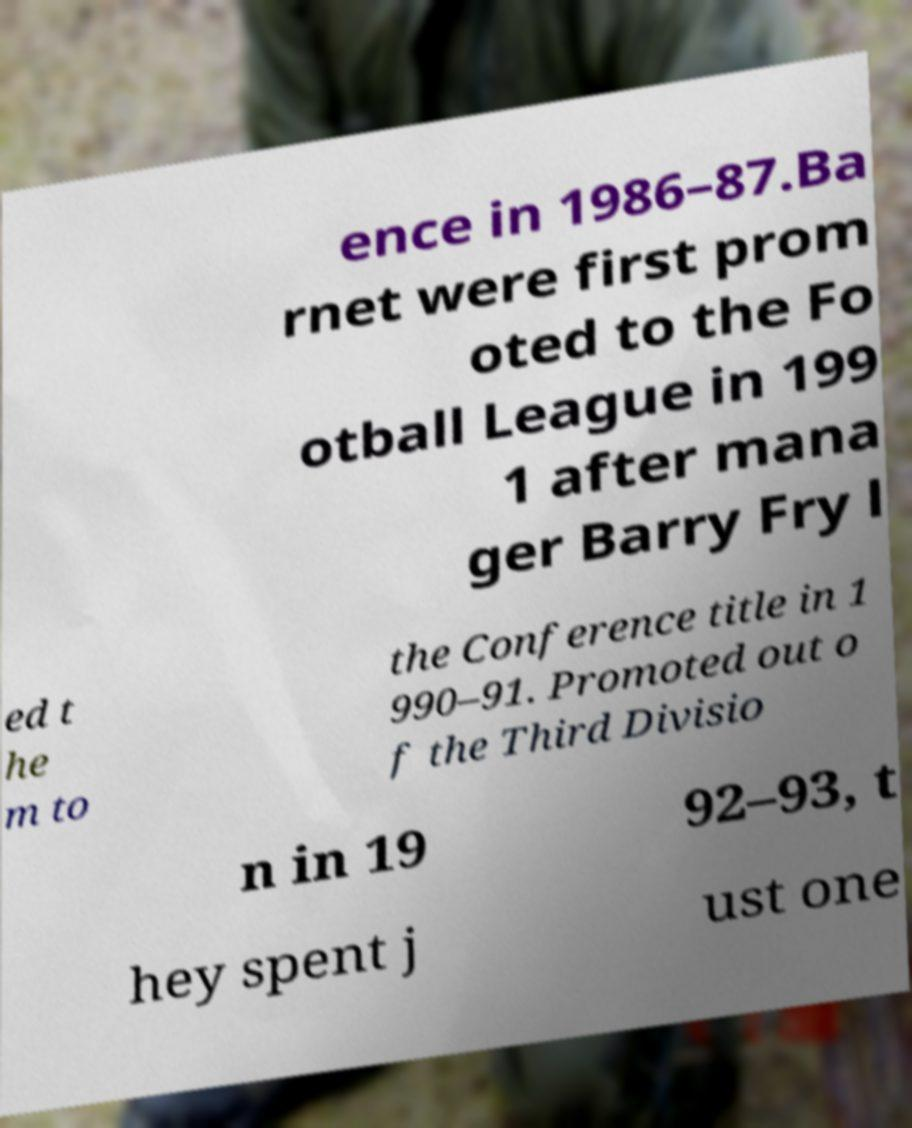Can you read and provide the text displayed in the image?This photo seems to have some interesting text. Can you extract and type it out for me? ence in 1986–87.Ba rnet were first prom oted to the Fo otball League in 199 1 after mana ger Barry Fry l ed t he m to the Conference title in 1 990–91. Promoted out o f the Third Divisio n in 19 92–93, t hey spent j ust one 